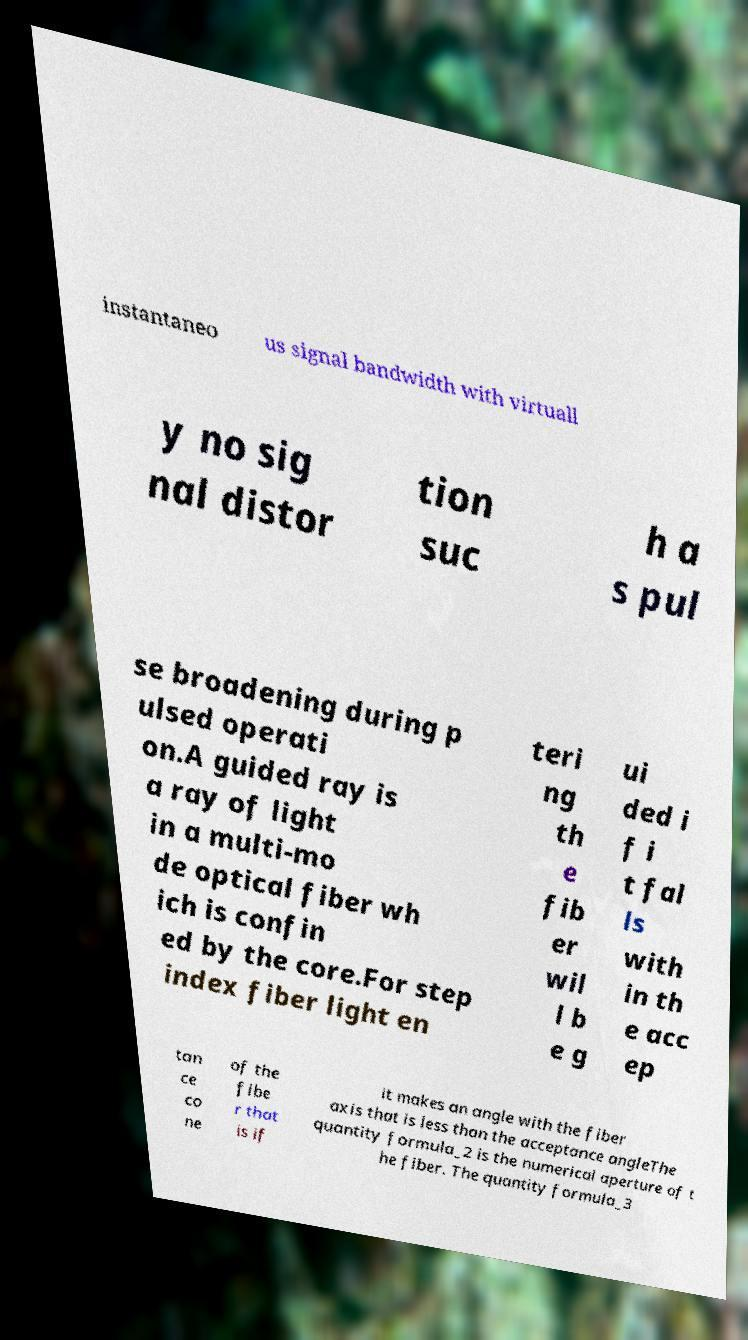Could you assist in decoding the text presented in this image and type it out clearly? instantaneo us signal bandwidth with virtuall y no sig nal distor tion suc h a s pul se broadening during p ulsed operati on.A guided ray is a ray of light in a multi-mo de optical fiber wh ich is confin ed by the core.For step index fiber light en teri ng th e fib er wil l b e g ui ded i f i t fal ls with in th e acc ep tan ce co ne of the fibe r that is if it makes an angle with the fiber axis that is less than the acceptance angleThe quantity formula_2 is the numerical aperture of t he fiber. The quantity formula_3 